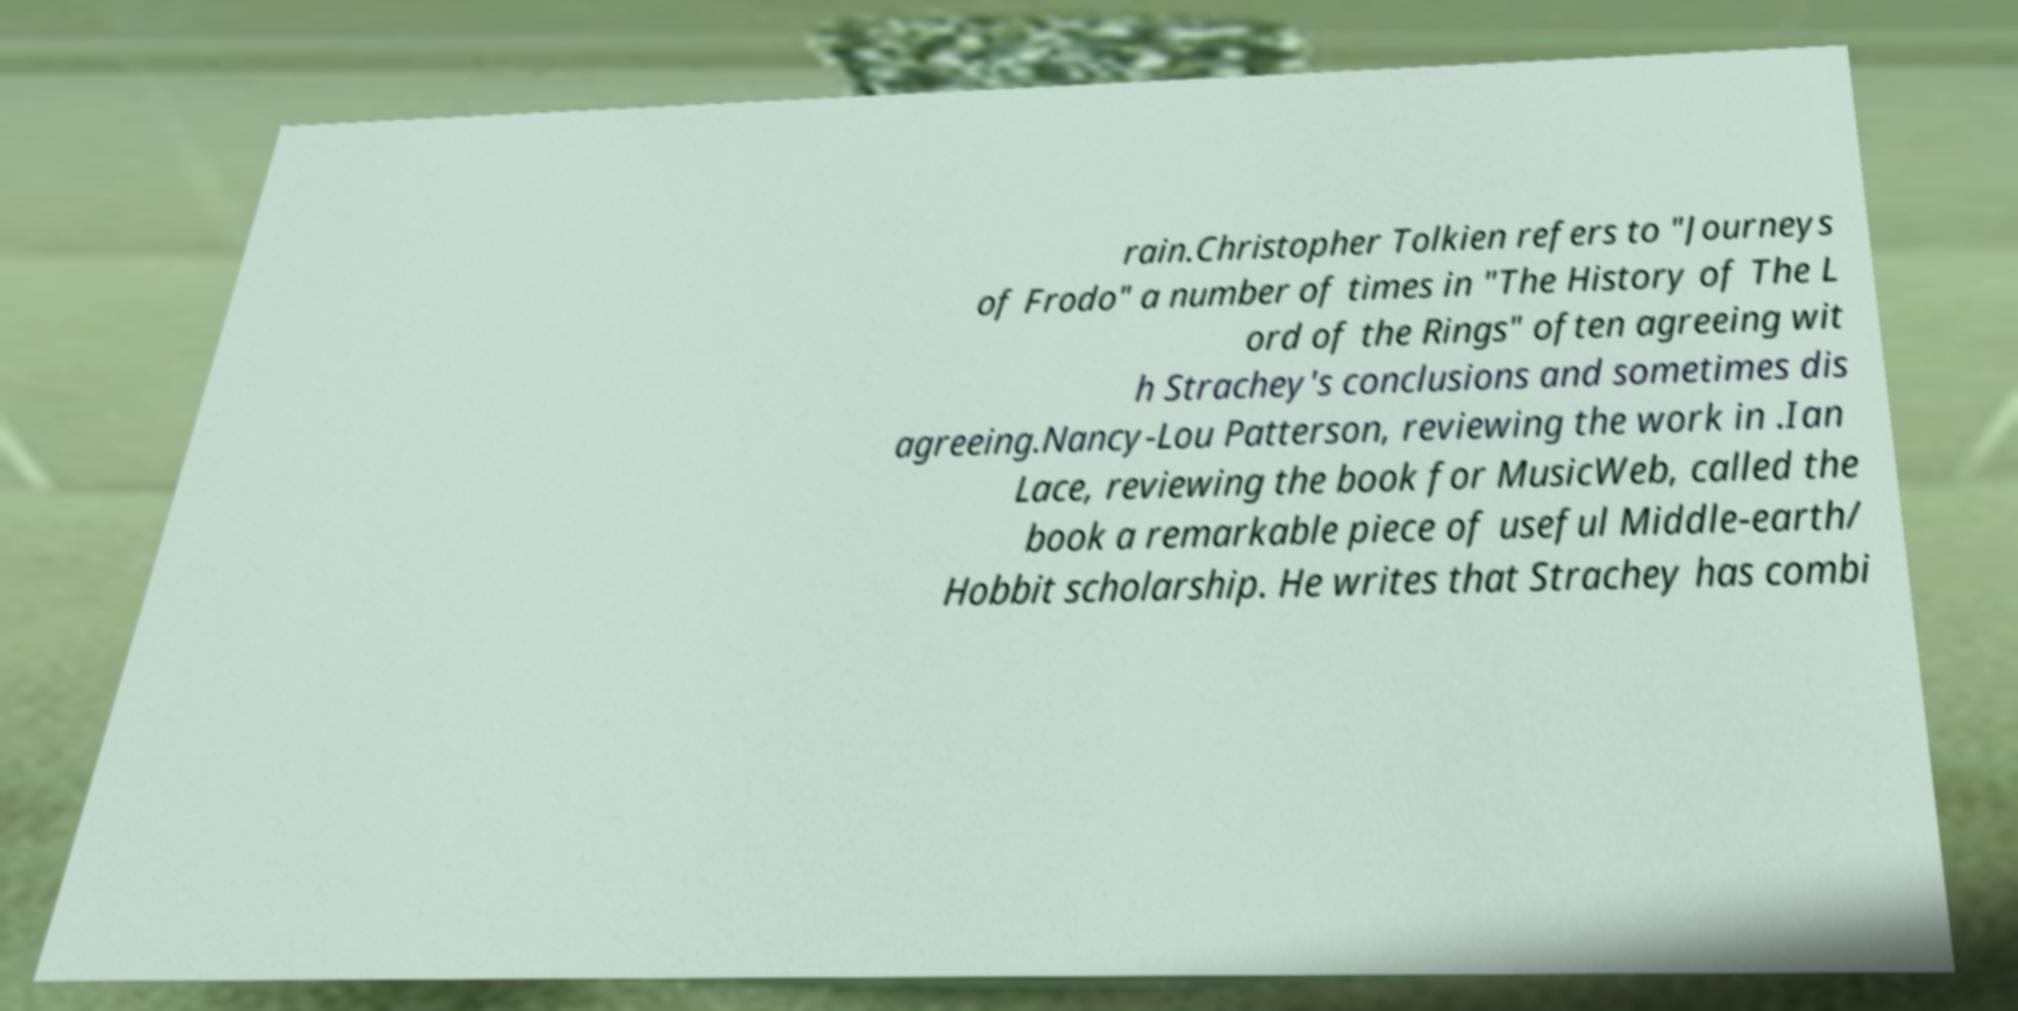Please read and relay the text visible in this image. What does it say? rain.Christopher Tolkien refers to "Journeys of Frodo" a number of times in "The History of The L ord of the Rings" often agreeing wit h Strachey's conclusions and sometimes dis agreeing.Nancy-Lou Patterson, reviewing the work in .Ian Lace, reviewing the book for MusicWeb, called the book a remarkable piece of useful Middle-earth/ Hobbit scholarship. He writes that Strachey has combi 